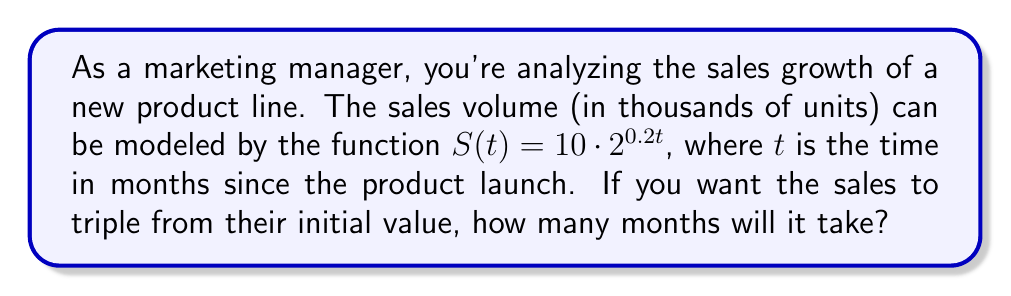Give your solution to this math problem. Let's approach this step-by-step:

1) The initial sales volume (at $t=0$) is:
   $S(0) = 10 \cdot 2^{0 \cdot 0.2} = 10$ thousand units

2) We want to find when the sales will be triple this amount, i.e., 30 thousand units. So we need to solve:
   $10 \cdot 2^{0.2t} = 30$

3) Dividing both sides by 10:
   $2^{0.2t} = 3$

4) Taking the logarithm (base 2) of both sides:
   $\log_2(2^{0.2t}) = \log_2(3)$

5) Using the logarithm property $\log_a(a^x) = x$:
   $0.2t = \log_2(3)$

6) Solving for $t$:
   $t = \frac{\log_2(3)}{0.2}$

7) We can change the base of the logarithm using the change of base formula:
   $t = \frac{\ln(3)}{\ln(2) \cdot 0.2}$

8) Calculating this:
   $t \approx 7.97$ months

Therefore, it will take approximately 7.97 months for the sales to triple.
Answer: $t \approx 7.97$ months 